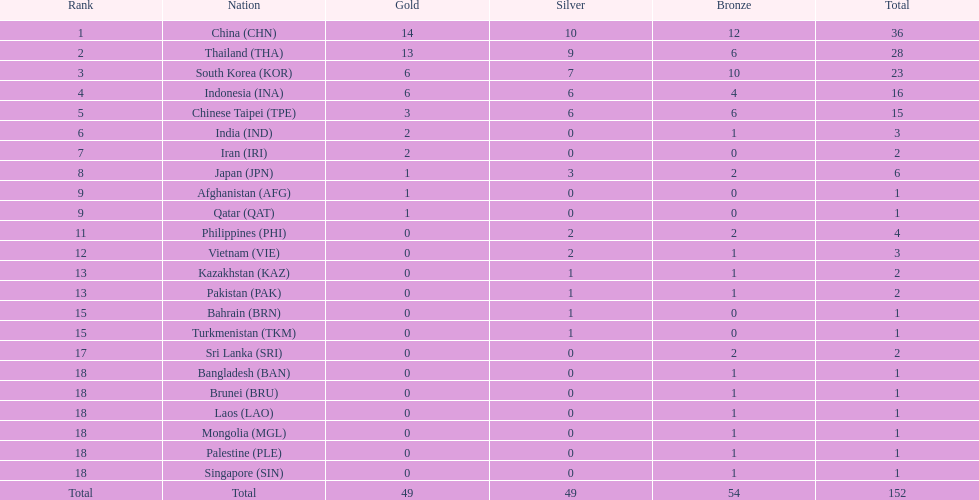In each of gold, silver, and bronze, how many nations were awarded a medal? 6. 